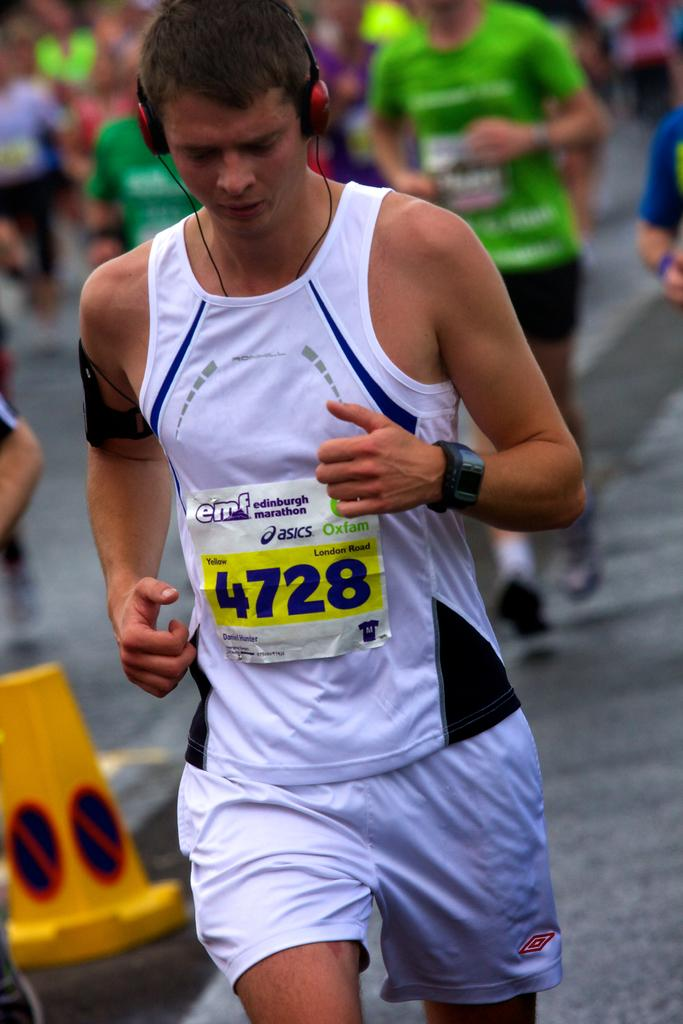Provide a one-sentence caption for the provided image. A young man wearking white shorts and a white vest bearing the number 4728 is running. 